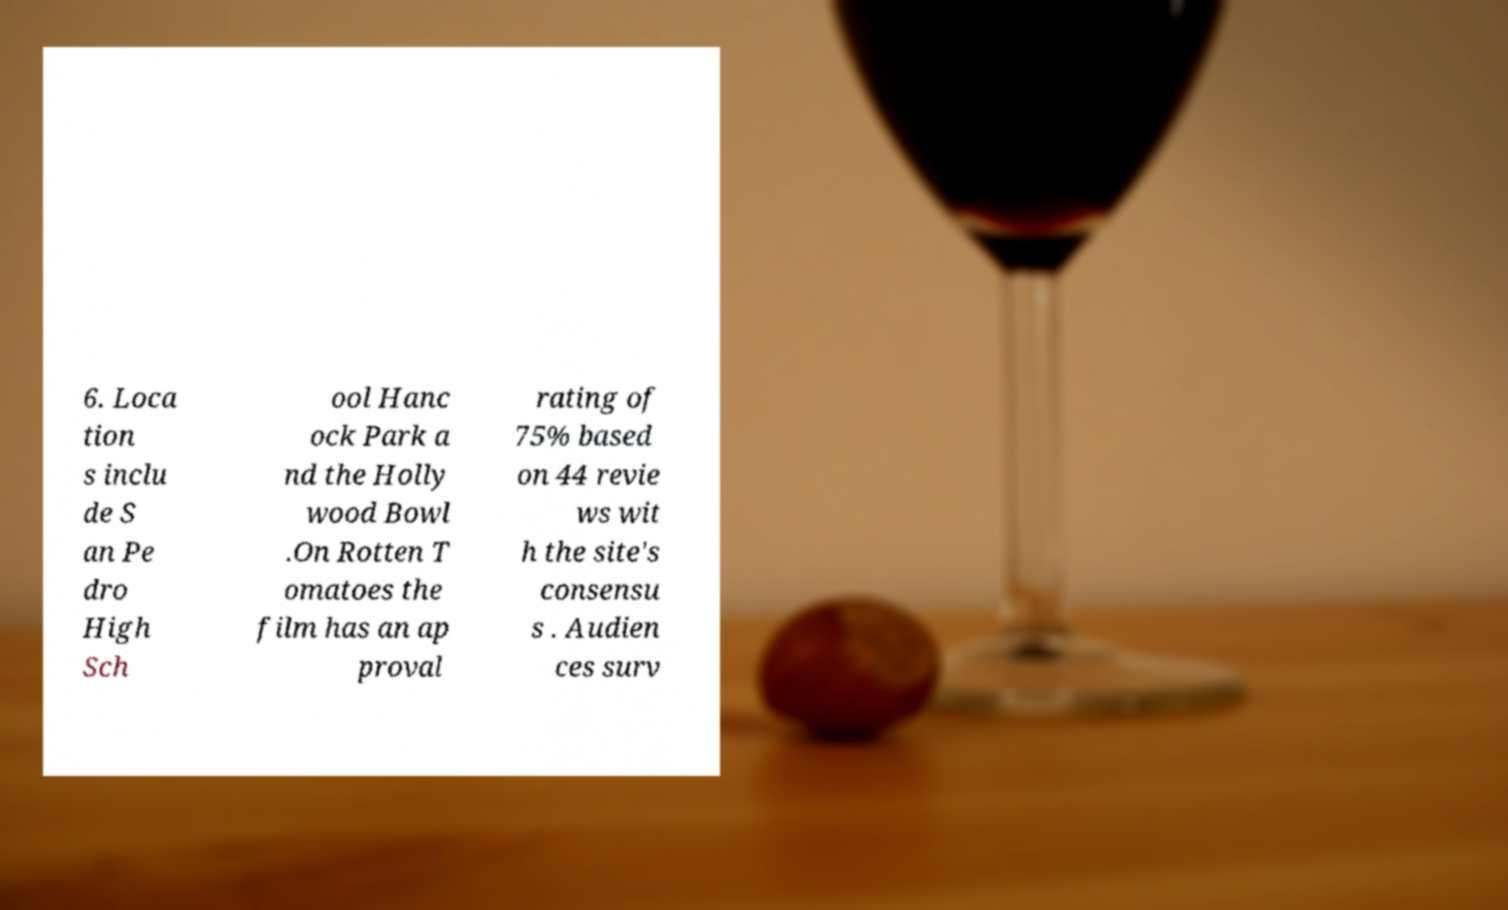For documentation purposes, I need the text within this image transcribed. Could you provide that? 6. Loca tion s inclu de S an Pe dro High Sch ool Hanc ock Park a nd the Holly wood Bowl .On Rotten T omatoes the film has an ap proval rating of 75% based on 44 revie ws wit h the site's consensu s . Audien ces surv 